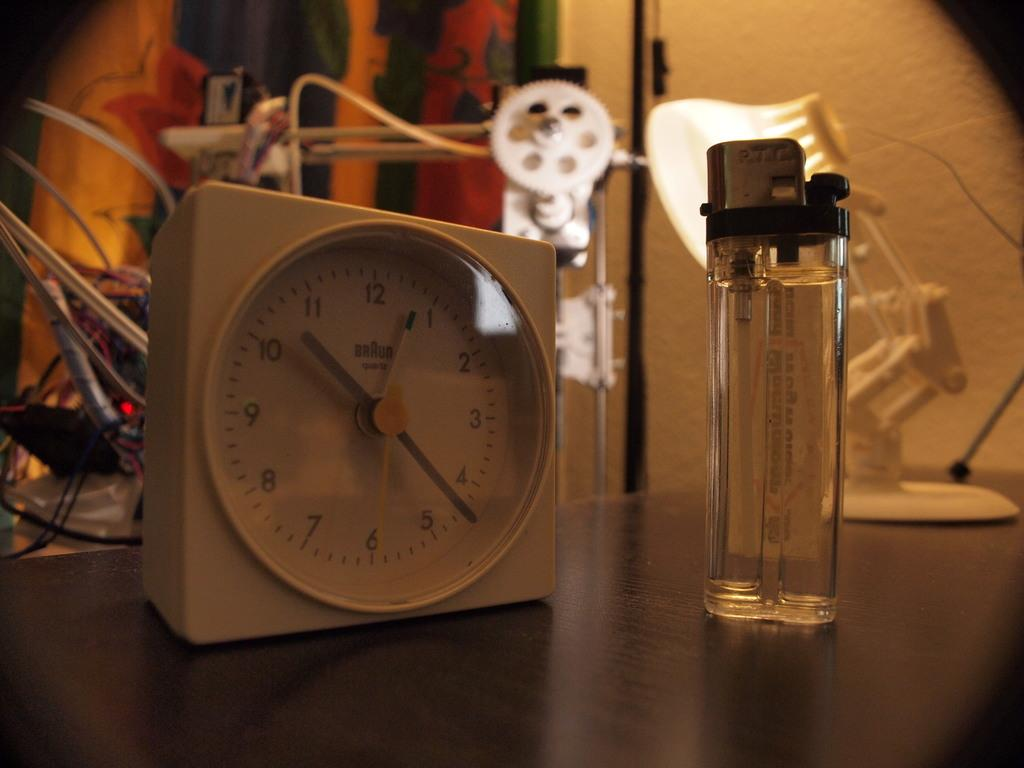<image>
Create a compact narrative representing the image presented. A Braun clock is on a table next to a lighter. 